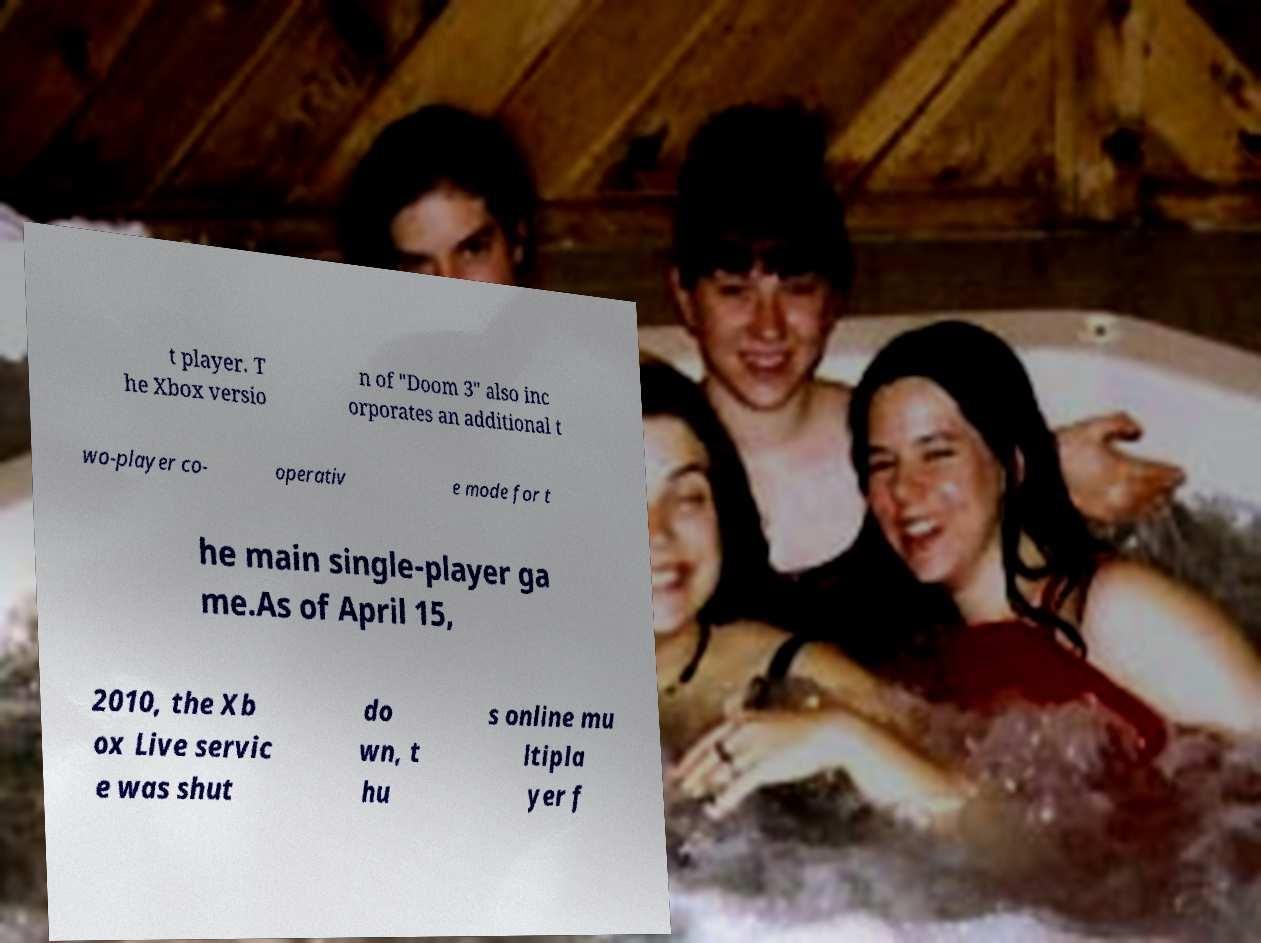Please identify and transcribe the text found in this image. t player. T he Xbox versio n of "Doom 3" also inc orporates an additional t wo-player co- operativ e mode for t he main single-player ga me.As of April 15, 2010, the Xb ox Live servic e was shut do wn, t hu s online mu ltipla yer f 